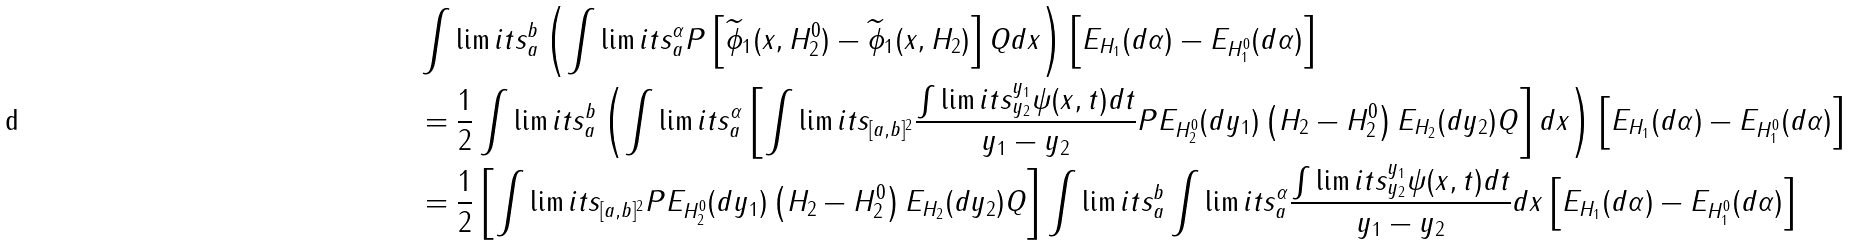<formula> <loc_0><loc_0><loc_500><loc_500>& \int \lim i t s _ { a } ^ { b } \left ( \int \lim i t s _ { a } ^ { \alpha } P \left [ \widetilde { \phi } _ { 1 } ( x , H _ { 2 } ^ { 0 } ) - \widetilde { \phi } _ { 1 } ( x , H _ { 2 } ) \right ] Q d x \right ) \left [ E _ { H _ { 1 } } ( d \alpha ) - E _ { H _ { 1 } ^ { 0 } } ( d \alpha ) \right ] \\ & = \frac { 1 } { 2 } \int \lim i t s _ { a } ^ { b } \left ( \int \lim i t s _ { a } ^ { \alpha } \left [ \int \lim i t s _ { [ a , b ] ^ { 2 } } \frac { \int \lim i t s _ { y _ { 2 } } ^ { y _ { 1 } } \psi ( x , t ) d t } { y _ { 1 } - y _ { 2 } } P E _ { H _ { 2 } ^ { 0 } } ( d y _ { 1 } ) \left ( H _ { 2 } - H _ { 2 } ^ { 0 } \right ) E _ { H _ { 2 } } ( d y _ { 2 } ) Q \right ] d x \right ) \left [ E _ { H _ { 1 } } ( d \alpha ) - E _ { H _ { 1 } ^ { 0 } } ( d \alpha ) \right ] \\ & = \frac { 1 } { 2 } \left [ \int \lim i t s _ { [ a , b ] ^ { 2 } } P E _ { H _ { 2 } ^ { 0 } } ( d y _ { 1 } ) \left ( H _ { 2 } - H _ { 2 } ^ { 0 } \right ) E _ { H _ { 2 } } ( d y _ { 2 } ) Q \right ] \int \lim i t s _ { a } ^ { b } \int \lim i t s _ { a } ^ { \alpha } \frac { \int \lim i t s _ { y _ { 2 } } ^ { y _ { 1 } } \psi ( x , t ) d t } { y _ { 1 } - y _ { 2 } } d x \left [ E _ { H _ { 1 } } ( d \alpha ) - E _ { H _ { 1 } ^ { 0 } } ( d \alpha ) \right ]</formula> 